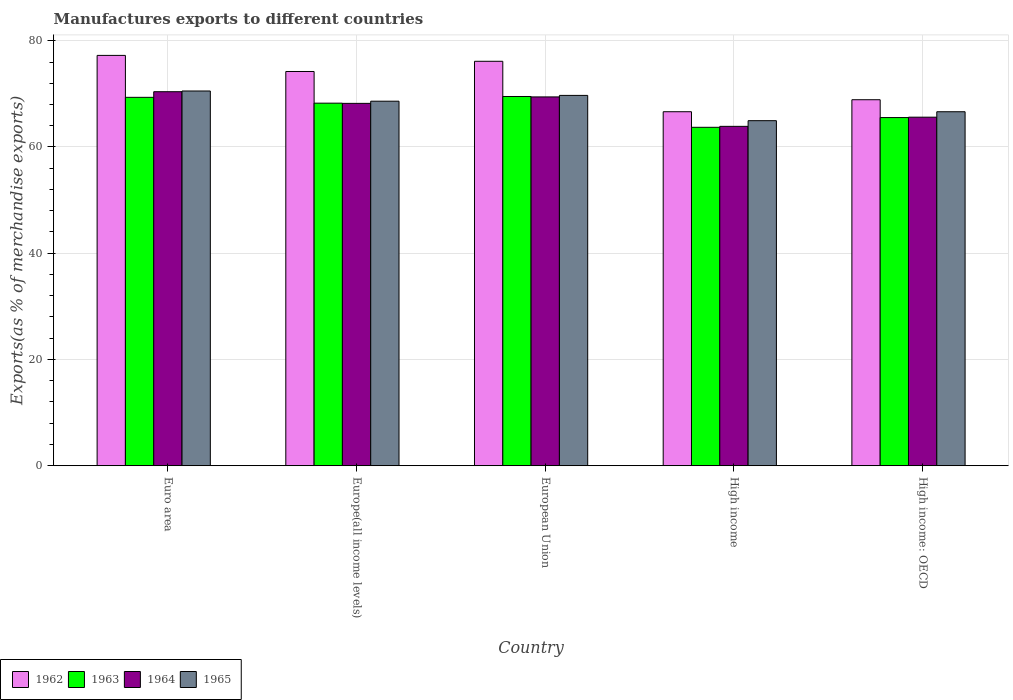How many different coloured bars are there?
Keep it short and to the point. 4. Are the number of bars per tick equal to the number of legend labels?
Give a very brief answer. Yes. Are the number of bars on each tick of the X-axis equal?
Ensure brevity in your answer.  Yes. How many bars are there on the 4th tick from the left?
Give a very brief answer. 4. How many bars are there on the 4th tick from the right?
Keep it short and to the point. 4. What is the label of the 5th group of bars from the left?
Provide a short and direct response. High income: OECD. What is the percentage of exports to different countries in 1963 in High income?
Ensure brevity in your answer.  63.71. Across all countries, what is the maximum percentage of exports to different countries in 1963?
Your answer should be compact. 69.51. Across all countries, what is the minimum percentage of exports to different countries in 1962?
Your response must be concise. 66.64. In which country was the percentage of exports to different countries in 1962 maximum?
Make the answer very short. Euro area. What is the total percentage of exports to different countries in 1964 in the graph?
Make the answer very short. 337.55. What is the difference between the percentage of exports to different countries in 1963 in Europe(all income levels) and that in European Union?
Offer a very short reply. -1.26. What is the difference between the percentage of exports to different countries in 1965 in Europe(all income levels) and the percentage of exports to different countries in 1962 in High income?
Make the answer very short. 1.98. What is the average percentage of exports to different countries in 1964 per country?
Ensure brevity in your answer.  67.51. What is the difference between the percentage of exports to different countries of/in 1965 and percentage of exports to different countries of/in 1963 in High income?
Your answer should be compact. 1.25. In how many countries, is the percentage of exports to different countries in 1965 greater than 40 %?
Your response must be concise. 5. What is the ratio of the percentage of exports to different countries in 1965 in European Union to that in High income?
Make the answer very short. 1.07. What is the difference between the highest and the second highest percentage of exports to different countries in 1962?
Offer a very short reply. -1.92. What is the difference between the highest and the lowest percentage of exports to different countries in 1963?
Ensure brevity in your answer.  5.8. In how many countries, is the percentage of exports to different countries in 1963 greater than the average percentage of exports to different countries in 1963 taken over all countries?
Offer a terse response. 3. Is the sum of the percentage of exports to different countries in 1962 in High income and High income: OECD greater than the maximum percentage of exports to different countries in 1965 across all countries?
Give a very brief answer. Yes. Is it the case that in every country, the sum of the percentage of exports to different countries in 1965 and percentage of exports to different countries in 1963 is greater than the sum of percentage of exports to different countries in 1962 and percentage of exports to different countries in 1964?
Your answer should be compact. No. What does the 1st bar from the left in Euro area represents?
Offer a very short reply. 1962. What does the 2nd bar from the right in High income: OECD represents?
Provide a succinct answer. 1964. What is the difference between two consecutive major ticks on the Y-axis?
Make the answer very short. 20. Does the graph contain any zero values?
Give a very brief answer. No. Where does the legend appear in the graph?
Offer a very short reply. Bottom left. What is the title of the graph?
Keep it short and to the point. Manufactures exports to different countries. What is the label or title of the Y-axis?
Ensure brevity in your answer.  Exports(as % of merchandise exports). What is the Exports(as % of merchandise exports) in 1962 in Euro area?
Provide a short and direct response. 77.24. What is the Exports(as % of merchandise exports) of 1963 in Euro area?
Your response must be concise. 69.35. What is the Exports(as % of merchandise exports) of 1964 in Euro area?
Your response must be concise. 70.41. What is the Exports(as % of merchandise exports) in 1965 in Euro area?
Provide a short and direct response. 70.54. What is the Exports(as % of merchandise exports) in 1962 in Europe(all income levels)?
Ensure brevity in your answer.  74.21. What is the Exports(as % of merchandise exports) of 1963 in Europe(all income levels)?
Your answer should be compact. 68.25. What is the Exports(as % of merchandise exports) of 1964 in Europe(all income levels)?
Provide a succinct answer. 68.21. What is the Exports(as % of merchandise exports) in 1965 in Europe(all income levels)?
Your response must be concise. 68.62. What is the Exports(as % of merchandise exports) in 1962 in European Union?
Keep it short and to the point. 76.13. What is the Exports(as % of merchandise exports) in 1963 in European Union?
Offer a terse response. 69.51. What is the Exports(as % of merchandise exports) in 1964 in European Union?
Your response must be concise. 69.43. What is the Exports(as % of merchandise exports) of 1965 in European Union?
Your answer should be compact. 69.71. What is the Exports(as % of merchandise exports) of 1962 in High income?
Provide a short and direct response. 66.64. What is the Exports(as % of merchandise exports) in 1963 in High income?
Ensure brevity in your answer.  63.71. What is the Exports(as % of merchandise exports) of 1964 in High income?
Your answer should be compact. 63.89. What is the Exports(as % of merchandise exports) in 1965 in High income?
Give a very brief answer. 64.96. What is the Exports(as % of merchandise exports) of 1962 in High income: OECD?
Keep it short and to the point. 68.9. What is the Exports(as % of merchandise exports) in 1963 in High income: OECD?
Offer a very short reply. 65.54. What is the Exports(as % of merchandise exports) in 1964 in High income: OECD?
Make the answer very short. 65.61. What is the Exports(as % of merchandise exports) in 1965 in High income: OECD?
Your answer should be compact. 66.64. Across all countries, what is the maximum Exports(as % of merchandise exports) in 1962?
Make the answer very short. 77.24. Across all countries, what is the maximum Exports(as % of merchandise exports) in 1963?
Ensure brevity in your answer.  69.51. Across all countries, what is the maximum Exports(as % of merchandise exports) of 1964?
Ensure brevity in your answer.  70.41. Across all countries, what is the maximum Exports(as % of merchandise exports) of 1965?
Offer a terse response. 70.54. Across all countries, what is the minimum Exports(as % of merchandise exports) of 1962?
Keep it short and to the point. 66.64. Across all countries, what is the minimum Exports(as % of merchandise exports) in 1963?
Your response must be concise. 63.71. Across all countries, what is the minimum Exports(as % of merchandise exports) of 1964?
Keep it short and to the point. 63.89. Across all countries, what is the minimum Exports(as % of merchandise exports) in 1965?
Provide a succinct answer. 64.96. What is the total Exports(as % of merchandise exports) of 1962 in the graph?
Keep it short and to the point. 363.13. What is the total Exports(as % of merchandise exports) of 1963 in the graph?
Give a very brief answer. 336.35. What is the total Exports(as % of merchandise exports) in 1964 in the graph?
Make the answer very short. 337.55. What is the total Exports(as % of merchandise exports) in 1965 in the graph?
Offer a terse response. 340.47. What is the difference between the Exports(as % of merchandise exports) of 1962 in Euro area and that in Europe(all income levels)?
Your answer should be compact. 3.03. What is the difference between the Exports(as % of merchandise exports) in 1963 in Euro area and that in Europe(all income levels)?
Offer a very short reply. 1.1. What is the difference between the Exports(as % of merchandise exports) of 1964 in Euro area and that in Europe(all income levels)?
Offer a very short reply. 2.19. What is the difference between the Exports(as % of merchandise exports) in 1965 in Euro area and that in Europe(all income levels)?
Provide a succinct answer. 1.92. What is the difference between the Exports(as % of merchandise exports) of 1962 in Euro area and that in European Union?
Ensure brevity in your answer.  1.11. What is the difference between the Exports(as % of merchandise exports) of 1963 in Euro area and that in European Union?
Your response must be concise. -0.16. What is the difference between the Exports(as % of merchandise exports) in 1964 in Euro area and that in European Union?
Give a very brief answer. 0.98. What is the difference between the Exports(as % of merchandise exports) of 1965 in Euro area and that in European Union?
Ensure brevity in your answer.  0.83. What is the difference between the Exports(as % of merchandise exports) of 1962 in Euro area and that in High income?
Make the answer very short. 10.6. What is the difference between the Exports(as % of merchandise exports) of 1963 in Euro area and that in High income?
Provide a succinct answer. 5.64. What is the difference between the Exports(as % of merchandise exports) in 1964 in Euro area and that in High income?
Keep it short and to the point. 6.52. What is the difference between the Exports(as % of merchandise exports) in 1965 in Euro area and that in High income?
Provide a succinct answer. 5.59. What is the difference between the Exports(as % of merchandise exports) in 1962 in Euro area and that in High income: OECD?
Your response must be concise. 8.35. What is the difference between the Exports(as % of merchandise exports) in 1963 in Euro area and that in High income: OECD?
Make the answer very short. 3.81. What is the difference between the Exports(as % of merchandise exports) in 1964 in Euro area and that in High income: OECD?
Your answer should be compact. 4.79. What is the difference between the Exports(as % of merchandise exports) in 1965 in Euro area and that in High income: OECD?
Offer a very short reply. 3.91. What is the difference between the Exports(as % of merchandise exports) of 1962 in Europe(all income levels) and that in European Union?
Provide a succinct answer. -1.92. What is the difference between the Exports(as % of merchandise exports) in 1963 in Europe(all income levels) and that in European Union?
Offer a very short reply. -1.26. What is the difference between the Exports(as % of merchandise exports) in 1964 in Europe(all income levels) and that in European Union?
Your response must be concise. -1.22. What is the difference between the Exports(as % of merchandise exports) of 1965 in Europe(all income levels) and that in European Union?
Your response must be concise. -1.09. What is the difference between the Exports(as % of merchandise exports) in 1962 in Europe(all income levels) and that in High income?
Ensure brevity in your answer.  7.57. What is the difference between the Exports(as % of merchandise exports) of 1963 in Europe(all income levels) and that in High income?
Ensure brevity in your answer.  4.54. What is the difference between the Exports(as % of merchandise exports) in 1964 in Europe(all income levels) and that in High income?
Make the answer very short. 4.33. What is the difference between the Exports(as % of merchandise exports) in 1965 in Europe(all income levels) and that in High income?
Ensure brevity in your answer.  3.67. What is the difference between the Exports(as % of merchandise exports) in 1962 in Europe(all income levels) and that in High income: OECD?
Ensure brevity in your answer.  5.32. What is the difference between the Exports(as % of merchandise exports) of 1963 in Europe(all income levels) and that in High income: OECD?
Your response must be concise. 2.71. What is the difference between the Exports(as % of merchandise exports) in 1964 in Europe(all income levels) and that in High income: OECD?
Offer a very short reply. 2.6. What is the difference between the Exports(as % of merchandise exports) in 1965 in Europe(all income levels) and that in High income: OECD?
Provide a short and direct response. 1.99. What is the difference between the Exports(as % of merchandise exports) in 1962 in European Union and that in High income?
Offer a very short reply. 9.49. What is the difference between the Exports(as % of merchandise exports) in 1963 in European Union and that in High income?
Keep it short and to the point. 5.8. What is the difference between the Exports(as % of merchandise exports) of 1964 in European Union and that in High income?
Your response must be concise. 5.54. What is the difference between the Exports(as % of merchandise exports) in 1965 in European Union and that in High income?
Offer a terse response. 4.76. What is the difference between the Exports(as % of merchandise exports) in 1962 in European Union and that in High income: OECD?
Offer a very short reply. 7.23. What is the difference between the Exports(as % of merchandise exports) of 1963 in European Union and that in High income: OECD?
Your response must be concise. 3.97. What is the difference between the Exports(as % of merchandise exports) of 1964 in European Union and that in High income: OECD?
Offer a very short reply. 3.81. What is the difference between the Exports(as % of merchandise exports) in 1965 in European Union and that in High income: OECD?
Your response must be concise. 3.07. What is the difference between the Exports(as % of merchandise exports) of 1962 in High income and that in High income: OECD?
Your answer should be compact. -2.26. What is the difference between the Exports(as % of merchandise exports) of 1963 in High income and that in High income: OECD?
Provide a succinct answer. -1.83. What is the difference between the Exports(as % of merchandise exports) of 1964 in High income and that in High income: OECD?
Your response must be concise. -1.73. What is the difference between the Exports(as % of merchandise exports) of 1965 in High income and that in High income: OECD?
Make the answer very short. -1.68. What is the difference between the Exports(as % of merchandise exports) in 1962 in Euro area and the Exports(as % of merchandise exports) in 1963 in Europe(all income levels)?
Provide a succinct answer. 8.99. What is the difference between the Exports(as % of merchandise exports) in 1962 in Euro area and the Exports(as % of merchandise exports) in 1964 in Europe(all income levels)?
Provide a short and direct response. 9.03. What is the difference between the Exports(as % of merchandise exports) in 1962 in Euro area and the Exports(as % of merchandise exports) in 1965 in Europe(all income levels)?
Offer a very short reply. 8.62. What is the difference between the Exports(as % of merchandise exports) in 1963 in Euro area and the Exports(as % of merchandise exports) in 1964 in Europe(all income levels)?
Your answer should be very brief. 1.14. What is the difference between the Exports(as % of merchandise exports) of 1963 in Euro area and the Exports(as % of merchandise exports) of 1965 in Europe(all income levels)?
Make the answer very short. 0.73. What is the difference between the Exports(as % of merchandise exports) of 1964 in Euro area and the Exports(as % of merchandise exports) of 1965 in Europe(all income levels)?
Offer a terse response. 1.78. What is the difference between the Exports(as % of merchandise exports) in 1962 in Euro area and the Exports(as % of merchandise exports) in 1963 in European Union?
Make the answer very short. 7.74. What is the difference between the Exports(as % of merchandise exports) in 1962 in Euro area and the Exports(as % of merchandise exports) in 1964 in European Union?
Provide a short and direct response. 7.82. What is the difference between the Exports(as % of merchandise exports) in 1962 in Euro area and the Exports(as % of merchandise exports) in 1965 in European Union?
Provide a short and direct response. 7.53. What is the difference between the Exports(as % of merchandise exports) of 1963 in Euro area and the Exports(as % of merchandise exports) of 1964 in European Union?
Make the answer very short. -0.08. What is the difference between the Exports(as % of merchandise exports) in 1963 in Euro area and the Exports(as % of merchandise exports) in 1965 in European Union?
Offer a very short reply. -0.36. What is the difference between the Exports(as % of merchandise exports) in 1964 in Euro area and the Exports(as % of merchandise exports) in 1965 in European Union?
Ensure brevity in your answer.  0.69. What is the difference between the Exports(as % of merchandise exports) in 1962 in Euro area and the Exports(as % of merchandise exports) in 1963 in High income?
Keep it short and to the point. 13.54. What is the difference between the Exports(as % of merchandise exports) of 1962 in Euro area and the Exports(as % of merchandise exports) of 1964 in High income?
Keep it short and to the point. 13.36. What is the difference between the Exports(as % of merchandise exports) in 1962 in Euro area and the Exports(as % of merchandise exports) in 1965 in High income?
Offer a very short reply. 12.29. What is the difference between the Exports(as % of merchandise exports) in 1963 in Euro area and the Exports(as % of merchandise exports) in 1964 in High income?
Give a very brief answer. 5.46. What is the difference between the Exports(as % of merchandise exports) of 1963 in Euro area and the Exports(as % of merchandise exports) of 1965 in High income?
Ensure brevity in your answer.  4.39. What is the difference between the Exports(as % of merchandise exports) in 1964 in Euro area and the Exports(as % of merchandise exports) in 1965 in High income?
Provide a succinct answer. 5.45. What is the difference between the Exports(as % of merchandise exports) in 1962 in Euro area and the Exports(as % of merchandise exports) in 1963 in High income: OECD?
Your answer should be compact. 11.71. What is the difference between the Exports(as % of merchandise exports) in 1962 in Euro area and the Exports(as % of merchandise exports) in 1964 in High income: OECD?
Your answer should be very brief. 11.63. What is the difference between the Exports(as % of merchandise exports) of 1962 in Euro area and the Exports(as % of merchandise exports) of 1965 in High income: OECD?
Offer a terse response. 10.61. What is the difference between the Exports(as % of merchandise exports) of 1963 in Euro area and the Exports(as % of merchandise exports) of 1964 in High income: OECD?
Give a very brief answer. 3.73. What is the difference between the Exports(as % of merchandise exports) in 1963 in Euro area and the Exports(as % of merchandise exports) in 1965 in High income: OECD?
Offer a very short reply. 2.71. What is the difference between the Exports(as % of merchandise exports) in 1964 in Euro area and the Exports(as % of merchandise exports) in 1965 in High income: OECD?
Your response must be concise. 3.77. What is the difference between the Exports(as % of merchandise exports) of 1962 in Europe(all income levels) and the Exports(as % of merchandise exports) of 1963 in European Union?
Your response must be concise. 4.71. What is the difference between the Exports(as % of merchandise exports) in 1962 in Europe(all income levels) and the Exports(as % of merchandise exports) in 1964 in European Union?
Offer a very short reply. 4.79. What is the difference between the Exports(as % of merchandise exports) of 1962 in Europe(all income levels) and the Exports(as % of merchandise exports) of 1965 in European Union?
Offer a very short reply. 4.5. What is the difference between the Exports(as % of merchandise exports) of 1963 in Europe(all income levels) and the Exports(as % of merchandise exports) of 1964 in European Union?
Your answer should be compact. -1.18. What is the difference between the Exports(as % of merchandise exports) in 1963 in Europe(all income levels) and the Exports(as % of merchandise exports) in 1965 in European Union?
Your answer should be compact. -1.46. What is the difference between the Exports(as % of merchandise exports) of 1964 in Europe(all income levels) and the Exports(as % of merchandise exports) of 1965 in European Union?
Offer a very short reply. -1.5. What is the difference between the Exports(as % of merchandise exports) of 1962 in Europe(all income levels) and the Exports(as % of merchandise exports) of 1963 in High income?
Your response must be concise. 10.51. What is the difference between the Exports(as % of merchandise exports) of 1962 in Europe(all income levels) and the Exports(as % of merchandise exports) of 1964 in High income?
Ensure brevity in your answer.  10.33. What is the difference between the Exports(as % of merchandise exports) in 1962 in Europe(all income levels) and the Exports(as % of merchandise exports) in 1965 in High income?
Keep it short and to the point. 9.26. What is the difference between the Exports(as % of merchandise exports) of 1963 in Europe(all income levels) and the Exports(as % of merchandise exports) of 1964 in High income?
Provide a short and direct response. 4.36. What is the difference between the Exports(as % of merchandise exports) in 1963 in Europe(all income levels) and the Exports(as % of merchandise exports) in 1965 in High income?
Your response must be concise. 3.3. What is the difference between the Exports(as % of merchandise exports) in 1964 in Europe(all income levels) and the Exports(as % of merchandise exports) in 1965 in High income?
Offer a terse response. 3.26. What is the difference between the Exports(as % of merchandise exports) in 1962 in Europe(all income levels) and the Exports(as % of merchandise exports) in 1963 in High income: OECD?
Provide a short and direct response. 8.68. What is the difference between the Exports(as % of merchandise exports) of 1962 in Europe(all income levels) and the Exports(as % of merchandise exports) of 1964 in High income: OECD?
Give a very brief answer. 8.6. What is the difference between the Exports(as % of merchandise exports) in 1962 in Europe(all income levels) and the Exports(as % of merchandise exports) in 1965 in High income: OECD?
Offer a very short reply. 7.58. What is the difference between the Exports(as % of merchandise exports) in 1963 in Europe(all income levels) and the Exports(as % of merchandise exports) in 1964 in High income: OECD?
Your answer should be very brief. 2.64. What is the difference between the Exports(as % of merchandise exports) of 1963 in Europe(all income levels) and the Exports(as % of merchandise exports) of 1965 in High income: OECD?
Make the answer very short. 1.61. What is the difference between the Exports(as % of merchandise exports) in 1964 in Europe(all income levels) and the Exports(as % of merchandise exports) in 1965 in High income: OECD?
Make the answer very short. 1.57. What is the difference between the Exports(as % of merchandise exports) of 1962 in European Union and the Exports(as % of merchandise exports) of 1963 in High income?
Offer a very short reply. 12.42. What is the difference between the Exports(as % of merchandise exports) in 1962 in European Union and the Exports(as % of merchandise exports) in 1964 in High income?
Offer a terse response. 12.25. What is the difference between the Exports(as % of merchandise exports) of 1962 in European Union and the Exports(as % of merchandise exports) of 1965 in High income?
Give a very brief answer. 11.18. What is the difference between the Exports(as % of merchandise exports) of 1963 in European Union and the Exports(as % of merchandise exports) of 1964 in High income?
Offer a terse response. 5.62. What is the difference between the Exports(as % of merchandise exports) in 1963 in European Union and the Exports(as % of merchandise exports) in 1965 in High income?
Make the answer very short. 4.55. What is the difference between the Exports(as % of merchandise exports) in 1964 in European Union and the Exports(as % of merchandise exports) in 1965 in High income?
Offer a very short reply. 4.47. What is the difference between the Exports(as % of merchandise exports) of 1962 in European Union and the Exports(as % of merchandise exports) of 1963 in High income: OECD?
Your answer should be compact. 10.59. What is the difference between the Exports(as % of merchandise exports) of 1962 in European Union and the Exports(as % of merchandise exports) of 1964 in High income: OECD?
Make the answer very short. 10.52. What is the difference between the Exports(as % of merchandise exports) of 1962 in European Union and the Exports(as % of merchandise exports) of 1965 in High income: OECD?
Make the answer very short. 9.5. What is the difference between the Exports(as % of merchandise exports) in 1963 in European Union and the Exports(as % of merchandise exports) in 1964 in High income: OECD?
Your response must be concise. 3.89. What is the difference between the Exports(as % of merchandise exports) of 1963 in European Union and the Exports(as % of merchandise exports) of 1965 in High income: OECD?
Provide a succinct answer. 2.87. What is the difference between the Exports(as % of merchandise exports) in 1964 in European Union and the Exports(as % of merchandise exports) in 1965 in High income: OECD?
Your answer should be very brief. 2.79. What is the difference between the Exports(as % of merchandise exports) in 1962 in High income and the Exports(as % of merchandise exports) in 1963 in High income: OECD?
Your answer should be very brief. 1.1. What is the difference between the Exports(as % of merchandise exports) of 1962 in High income and the Exports(as % of merchandise exports) of 1964 in High income: OECD?
Keep it short and to the point. 1.03. What is the difference between the Exports(as % of merchandise exports) of 1962 in High income and the Exports(as % of merchandise exports) of 1965 in High income: OECD?
Give a very brief answer. 0. What is the difference between the Exports(as % of merchandise exports) in 1963 in High income and the Exports(as % of merchandise exports) in 1964 in High income: OECD?
Your response must be concise. -1.91. What is the difference between the Exports(as % of merchandise exports) in 1963 in High income and the Exports(as % of merchandise exports) in 1965 in High income: OECD?
Keep it short and to the point. -2.93. What is the difference between the Exports(as % of merchandise exports) of 1964 in High income and the Exports(as % of merchandise exports) of 1965 in High income: OECD?
Make the answer very short. -2.75. What is the average Exports(as % of merchandise exports) of 1962 per country?
Your answer should be very brief. 72.63. What is the average Exports(as % of merchandise exports) of 1963 per country?
Give a very brief answer. 67.27. What is the average Exports(as % of merchandise exports) in 1964 per country?
Keep it short and to the point. 67.51. What is the average Exports(as % of merchandise exports) in 1965 per country?
Your answer should be compact. 68.09. What is the difference between the Exports(as % of merchandise exports) of 1962 and Exports(as % of merchandise exports) of 1963 in Euro area?
Give a very brief answer. 7.9. What is the difference between the Exports(as % of merchandise exports) in 1962 and Exports(as % of merchandise exports) in 1964 in Euro area?
Provide a succinct answer. 6.84. What is the difference between the Exports(as % of merchandise exports) of 1962 and Exports(as % of merchandise exports) of 1965 in Euro area?
Offer a terse response. 6.7. What is the difference between the Exports(as % of merchandise exports) in 1963 and Exports(as % of merchandise exports) in 1964 in Euro area?
Keep it short and to the point. -1.06. What is the difference between the Exports(as % of merchandise exports) of 1963 and Exports(as % of merchandise exports) of 1965 in Euro area?
Your response must be concise. -1.19. What is the difference between the Exports(as % of merchandise exports) of 1964 and Exports(as % of merchandise exports) of 1965 in Euro area?
Make the answer very short. -0.14. What is the difference between the Exports(as % of merchandise exports) in 1962 and Exports(as % of merchandise exports) in 1963 in Europe(all income levels)?
Provide a succinct answer. 5.96. What is the difference between the Exports(as % of merchandise exports) of 1962 and Exports(as % of merchandise exports) of 1964 in Europe(all income levels)?
Your answer should be compact. 6. What is the difference between the Exports(as % of merchandise exports) in 1962 and Exports(as % of merchandise exports) in 1965 in Europe(all income levels)?
Your response must be concise. 5.59. What is the difference between the Exports(as % of merchandise exports) of 1963 and Exports(as % of merchandise exports) of 1964 in Europe(all income levels)?
Provide a succinct answer. 0.04. What is the difference between the Exports(as % of merchandise exports) in 1963 and Exports(as % of merchandise exports) in 1965 in Europe(all income levels)?
Make the answer very short. -0.37. What is the difference between the Exports(as % of merchandise exports) of 1964 and Exports(as % of merchandise exports) of 1965 in Europe(all income levels)?
Your answer should be very brief. -0.41. What is the difference between the Exports(as % of merchandise exports) of 1962 and Exports(as % of merchandise exports) of 1963 in European Union?
Offer a very short reply. 6.62. What is the difference between the Exports(as % of merchandise exports) of 1962 and Exports(as % of merchandise exports) of 1964 in European Union?
Ensure brevity in your answer.  6.71. What is the difference between the Exports(as % of merchandise exports) of 1962 and Exports(as % of merchandise exports) of 1965 in European Union?
Offer a very short reply. 6.42. What is the difference between the Exports(as % of merchandise exports) of 1963 and Exports(as % of merchandise exports) of 1964 in European Union?
Your response must be concise. 0.08. What is the difference between the Exports(as % of merchandise exports) in 1963 and Exports(as % of merchandise exports) in 1965 in European Union?
Your answer should be compact. -0.2. What is the difference between the Exports(as % of merchandise exports) in 1964 and Exports(as % of merchandise exports) in 1965 in European Union?
Provide a short and direct response. -0.28. What is the difference between the Exports(as % of merchandise exports) of 1962 and Exports(as % of merchandise exports) of 1963 in High income?
Provide a short and direct response. 2.93. What is the difference between the Exports(as % of merchandise exports) in 1962 and Exports(as % of merchandise exports) in 1964 in High income?
Your answer should be very brief. 2.75. What is the difference between the Exports(as % of merchandise exports) in 1962 and Exports(as % of merchandise exports) in 1965 in High income?
Your answer should be very brief. 1.68. What is the difference between the Exports(as % of merchandise exports) of 1963 and Exports(as % of merchandise exports) of 1964 in High income?
Provide a succinct answer. -0.18. What is the difference between the Exports(as % of merchandise exports) of 1963 and Exports(as % of merchandise exports) of 1965 in High income?
Give a very brief answer. -1.25. What is the difference between the Exports(as % of merchandise exports) in 1964 and Exports(as % of merchandise exports) in 1965 in High income?
Offer a very short reply. -1.07. What is the difference between the Exports(as % of merchandise exports) in 1962 and Exports(as % of merchandise exports) in 1963 in High income: OECD?
Make the answer very short. 3.36. What is the difference between the Exports(as % of merchandise exports) of 1962 and Exports(as % of merchandise exports) of 1964 in High income: OECD?
Your answer should be very brief. 3.28. What is the difference between the Exports(as % of merchandise exports) of 1962 and Exports(as % of merchandise exports) of 1965 in High income: OECD?
Provide a short and direct response. 2.26. What is the difference between the Exports(as % of merchandise exports) in 1963 and Exports(as % of merchandise exports) in 1964 in High income: OECD?
Ensure brevity in your answer.  -0.08. What is the difference between the Exports(as % of merchandise exports) in 1963 and Exports(as % of merchandise exports) in 1965 in High income: OECD?
Your answer should be very brief. -1.1. What is the difference between the Exports(as % of merchandise exports) of 1964 and Exports(as % of merchandise exports) of 1965 in High income: OECD?
Your answer should be compact. -1.02. What is the ratio of the Exports(as % of merchandise exports) of 1962 in Euro area to that in Europe(all income levels)?
Your answer should be very brief. 1.04. What is the ratio of the Exports(as % of merchandise exports) in 1963 in Euro area to that in Europe(all income levels)?
Make the answer very short. 1.02. What is the ratio of the Exports(as % of merchandise exports) of 1964 in Euro area to that in Europe(all income levels)?
Give a very brief answer. 1.03. What is the ratio of the Exports(as % of merchandise exports) of 1965 in Euro area to that in Europe(all income levels)?
Offer a very short reply. 1.03. What is the ratio of the Exports(as % of merchandise exports) of 1962 in Euro area to that in European Union?
Provide a succinct answer. 1.01. What is the ratio of the Exports(as % of merchandise exports) of 1963 in Euro area to that in European Union?
Your answer should be compact. 1. What is the ratio of the Exports(as % of merchandise exports) in 1964 in Euro area to that in European Union?
Offer a very short reply. 1.01. What is the ratio of the Exports(as % of merchandise exports) of 1965 in Euro area to that in European Union?
Provide a short and direct response. 1.01. What is the ratio of the Exports(as % of merchandise exports) of 1962 in Euro area to that in High income?
Your response must be concise. 1.16. What is the ratio of the Exports(as % of merchandise exports) of 1963 in Euro area to that in High income?
Your response must be concise. 1.09. What is the ratio of the Exports(as % of merchandise exports) of 1964 in Euro area to that in High income?
Ensure brevity in your answer.  1.1. What is the ratio of the Exports(as % of merchandise exports) of 1965 in Euro area to that in High income?
Keep it short and to the point. 1.09. What is the ratio of the Exports(as % of merchandise exports) in 1962 in Euro area to that in High income: OECD?
Provide a short and direct response. 1.12. What is the ratio of the Exports(as % of merchandise exports) in 1963 in Euro area to that in High income: OECD?
Offer a very short reply. 1.06. What is the ratio of the Exports(as % of merchandise exports) of 1964 in Euro area to that in High income: OECD?
Offer a terse response. 1.07. What is the ratio of the Exports(as % of merchandise exports) in 1965 in Euro area to that in High income: OECD?
Your answer should be compact. 1.06. What is the ratio of the Exports(as % of merchandise exports) of 1962 in Europe(all income levels) to that in European Union?
Your answer should be compact. 0.97. What is the ratio of the Exports(as % of merchandise exports) in 1963 in Europe(all income levels) to that in European Union?
Offer a very short reply. 0.98. What is the ratio of the Exports(as % of merchandise exports) of 1964 in Europe(all income levels) to that in European Union?
Give a very brief answer. 0.98. What is the ratio of the Exports(as % of merchandise exports) in 1965 in Europe(all income levels) to that in European Union?
Make the answer very short. 0.98. What is the ratio of the Exports(as % of merchandise exports) in 1962 in Europe(all income levels) to that in High income?
Your answer should be compact. 1.11. What is the ratio of the Exports(as % of merchandise exports) of 1963 in Europe(all income levels) to that in High income?
Offer a very short reply. 1.07. What is the ratio of the Exports(as % of merchandise exports) of 1964 in Europe(all income levels) to that in High income?
Keep it short and to the point. 1.07. What is the ratio of the Exports(as % of merchandise exports) in 1965 in Europe(all income levels) to that in High income?
Make the answer very short. 1.06. What is the ratio of the Exports(as % of merchandise exports) in 1962 in Europe(all income levels) to that in High income: OECD?
Offer a very short reply. 1.08. What is the ratio of the Exports(as % of merchandise exports) in 1963 in Europe(all income levels) to that in High income: OECD?
Offer a terse response. 1.04. What is the ratio of the Exports(as % of merchandise exports) in 1964 in Europe(all income levels) to that in High income: OECD?
Provide a succinct answer. 1.04. What is the ratio of the Exports(as % of merchandise exports) of 1965 in Europe(all income levels) to that in High income: OECD?
Provide a succinct answer. 1.03. What is the ratio of the Exports(as % of merchandise exports) in 1962 in European Union to that in High income?
Your answer should be very brief. 1.14. What is the ratio of the Exports(as % of merchandise exports) of 1963 in European Union to that in High income?
Offer a very short reply. 1.09. What is the ratio of the Exports(as % of merchandise exports) of 1964 in European Union to that in High income?
Keep it short and to the point. 1.09. What is the ratio of the Exports(as % of merchandise exports) in 1965 in European Union to that in High income?
Provide a succinct answer. 1.07. What is the ratio of the Exports(as % of merchandise exports) of 1962 in European Union to that in High income: OECD?
Offer a very short reply. 1.1. What is the ratio of the Exports(as % of merchandise exports) in 1963 in European Union to that in High income: OECD?
Your response must be concise. 1.06. What is the ratio of the Exports(as % of merchandise exports) in 1964 in European Union to that in High income: OECD?
Ensure brevity in your answer.  1.06. What is the ratio of the Exports(as % of merchandise exports) of 1965 in European Union to that in High income: OECD?
Ensure brevity in your answer.  1.05. What is the ratio of the Exports(as % of merchandise exports) in 1962 in High income to that in High income: OECD?
Ensure brevity in your answer.  0.97. What is the ratio of the Exports(as % of merchandise exports) in 1963 in High income to that in High income: OECD?
Your response must be concise. 0.97. What is the ratio of the Exports(as % of merchandise exports) in 1964 in High income to that in High income: OECD?
Provide a succinct answer. 0.97. What is the ratio of the Exports(as % of merchandise exports) of 1965 in High income to that in High income: OECD?
Give a very brief answer. 0.97. What is the difference between the highest and the second highest Exports(as % of merchandise exports) of 1962?
Make the answer very short. 1.11. What is the difference between the highest and the second highest Exports(as % of merchandise exports) of 1963?
Your response must be concise. 0.16. What is the difference between the highest and the second highest Exports(as % of merchandise exports) in 1964?
Offer a very short reply. 0.98. What is the difference between the highest and the second highest Exports(as % of merchandise exports) of 1965?
Your answer should be very brief. 0.83. What is the difference between the highest and the lowest Exports(as % of merchandise exports) in 1962?
Your answer should be very brief. 10.6. What is the difference between the highest and the lowest Exports(as % of merchandise exports) in 1963?
Your response must be concise. 5.8. What is the difference between the highest and the lowest Exports(as % of merchandise exports) of 1964?
Make the answer very short. 6.52. What is the difference between the highest and the lowest Exports(as % of merchandise exports) of 1965?
Keep it short and to the point. 5.59. 